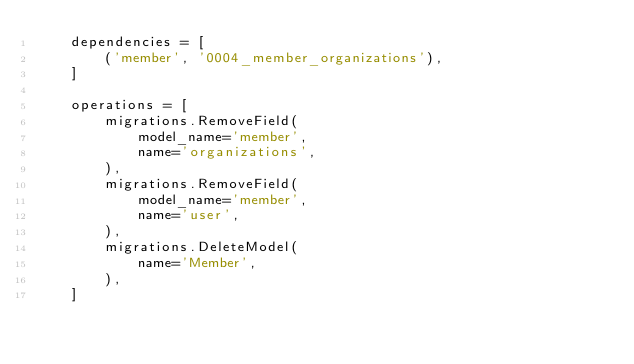Convert code to text. <code><loc_0><loc_0><loc_500><loc_500><_Python_>    dependencies = [
        ('member', '0004_member_organizations'),
    ]

    operations = [
        migrations.RemoveField(
            model_name='member',
            name='organizations',
        ),
        migrations.RemoveField(
            model_name='member',
            name='user',
        ),
        migrations.DeleteModel(
            name='Member',
        ),
    ]
</code> 